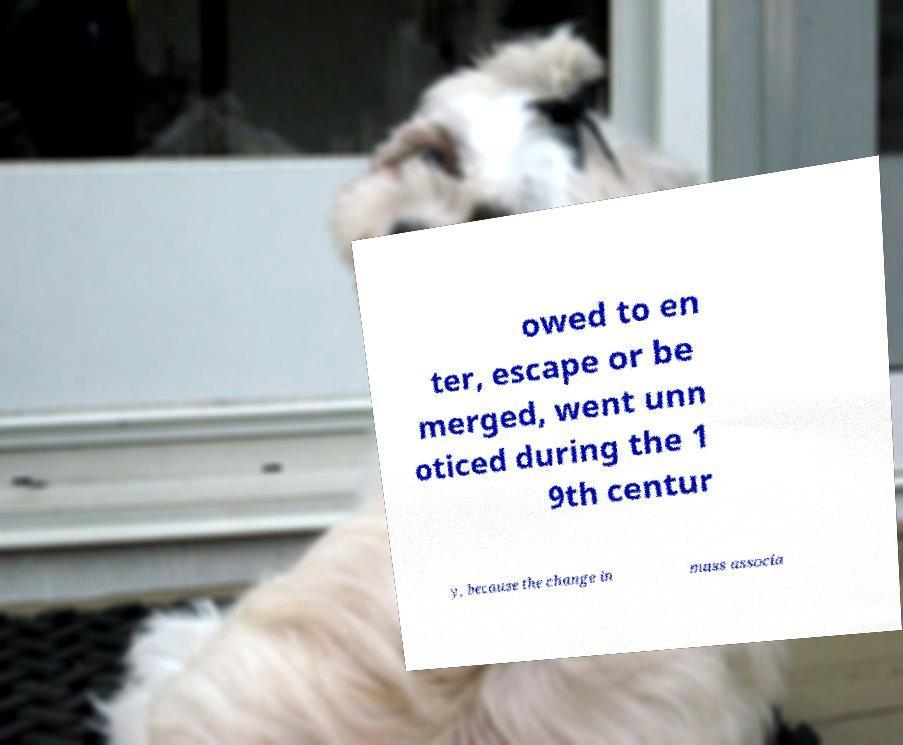I need the written content from this picture converted into text. Can you do that? owed to en ter, escape or be merged, went unn oticed during the 1 9th centur y, because the change in mass associa 